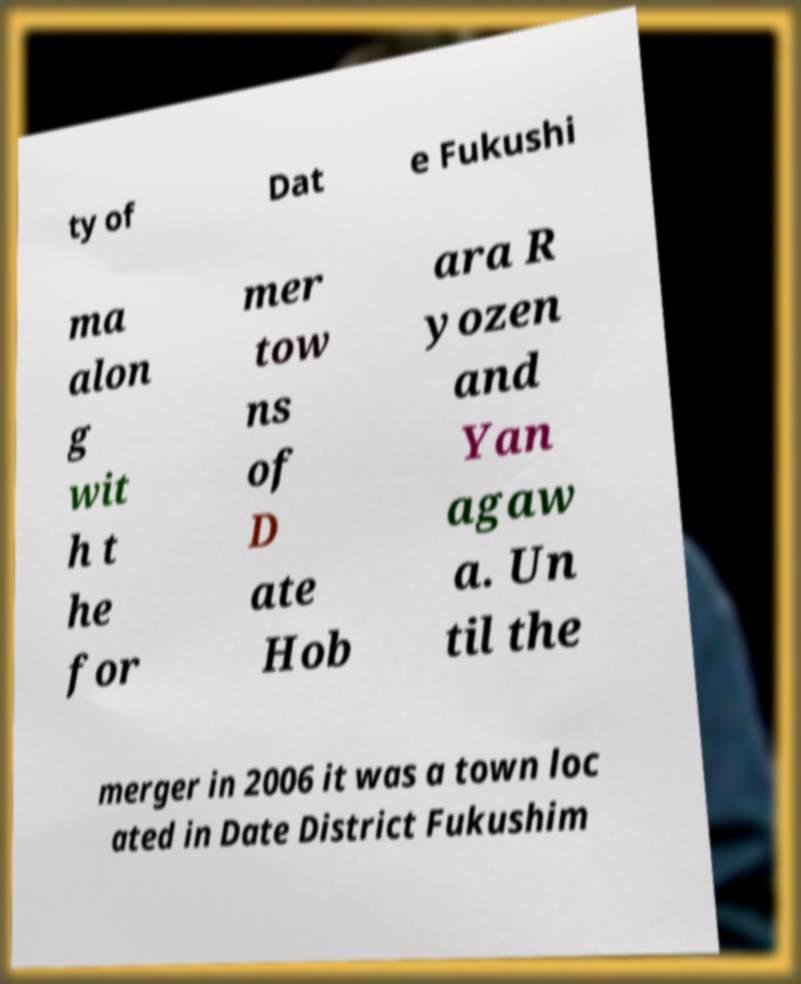Can you accurately transcribe the text from the provided image for me? ty of Dat e Fukushi ma alon g wit h t he for mer tow ns of D ate Hob ara R yozen and Yan agaw a. Un til the merger in 2006 it was a town loc ated in Date District Fukushim 